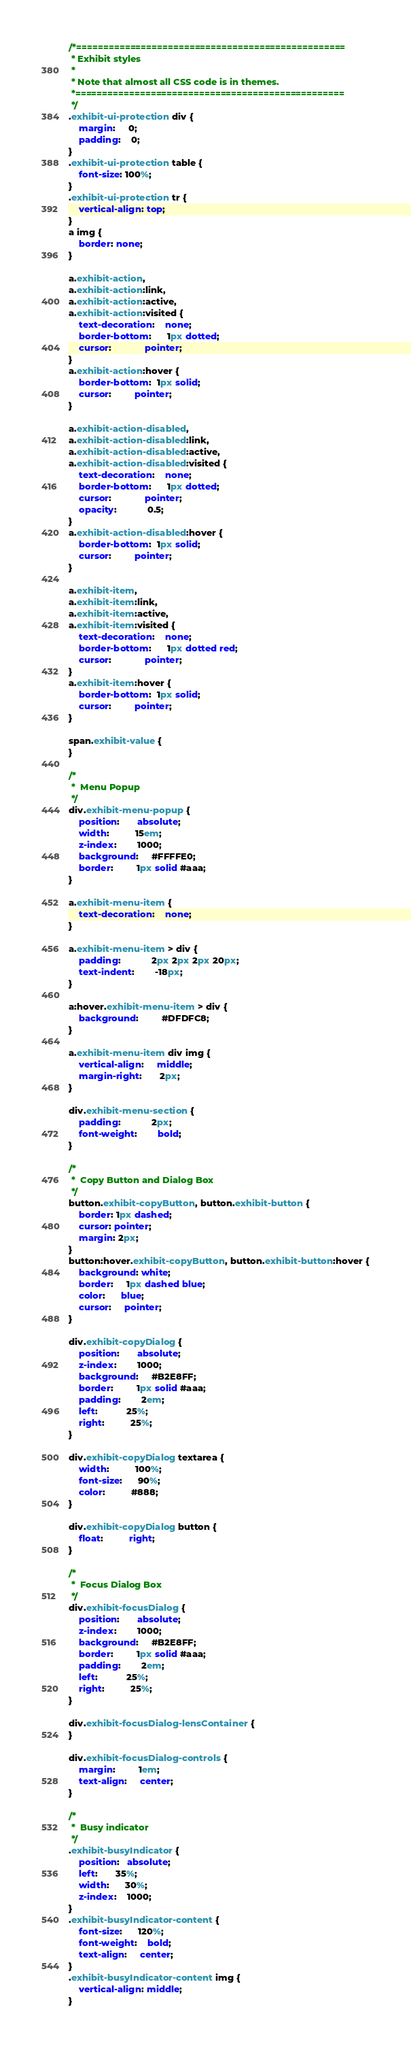Convert code to text. <code><loc_0><loc_0><loc_500><loc_500><_CSS_>/*==================================================
 * Exhibit styles
 *
 * Note that almost all CSS code is in themes.
 *==================================================
 */
.exhibit-ui-protection div {
    margin:     0;
    padding:    0;
}
.exhibit-ui-protection table {
	font-size: 100%;
}
.exhibit-ui-protection tr {
	vertical-align: top;
}
a img {
    border: none;
}

a.exhibit-action, 
a.exhibit-action:link, 
a.exhibit-action:active, 
a.exhibit-action:visited {
	text-decoration:    none;
	border-bottom:      1px dotted;
	cursor:             pointer;
}
a.exhibit-action:hover {
	border-bottom:  1px solid;
	cursor:         pointer;
}

a.exhibit-action-disabled, 
a.exhibit-action-disabled:link, 
a.exhibit-action-disabled:active, 
a.exhibit-action-disabled:visited {
	text-decoration:    none;
	border-bottom:      1px dotted;
	cursor:             pointer;
    opacity:            0.5;
}
a.exhibit-action-disabled:hover {
	border-bottom:  1px solid;
	cursor:         pointer;
}

a.exhibit-item, 
a.exhibit-item:link, 
a.exhibit-item:active, 
a.exhibit-item:visited {
	text-decoration:    none;
	border-bottom:      1px dotted red;
	cursor:             pointer;
}
a.exhibit-item:hover {
	border-bottom:  1px solid;
	cursor:         pointer;
}

span.exhibit-value {
}

/*
 *  Menu Popup
 */
div.exhibit-menu-popup {
    position:       absolute;
    width:          15em;
    z-index:        1000;
    background:     #FFFFE0;
    border:         1px solid #aaa;
}

a.exhibit-menu-item {
    text-decoration:    none;
}

a.exhibit-menu-item > div {
    padding:            2px 2px 2px 20px;
    text-indent:        -18px;
}

a:hover.exhibit-menu-item > div {
    background:         #DFDFC8;
}

a.exhibit-menu-item div img {
    vertical-align:     middle;
    margin-right:       2px;
}

div.exhibit-menu-section {
    padding:            2px;
    font-weight:        bold;
}

/*
 *  Copy Button and Dialog Box
 */
button.exhibit-copyButton, button.exhibit-button {
    border: 1px dashed;
    cursor: pointer;
    margin: 2px;
}
button:hover.exhibit-copyButton, button.exhibit-button:hover {
    background: white;
    border:     1px dashed blue;
    color:      blue;
    cursor:     pointer;
}

div.exhibit-copyDialog {
    position:       absolute;
    z-index:        1000;
    background:     #B2E8FF;
    border:         1px solid #aaa;
    padding:        2em;
    left:           25%;
    right:          25%;
}

div.exhibit-copyDialog textarea {
    width:          100%;
    font-size:      90%;
    color:          #888;
}

div.exhibit-copyDialog button {
    float:          right;
}

/*
 *  Focus Dialog Box
 */
div.exhibit-focusDialog {
    position:       absolute;
    z-index:        1000;
    background:     #B2E8FF;
    border:         1px solid #aaa;
    padding:        2em;
    left:           25%;
    right:          25%;
}

div.exhibit-focusDialog-lensContainer {
}

div.exhibit-focusDialog-controls {
    margin:         1em;
    text-align:     center;
}

/*
 *  Busy indicator
 */
.exhibit-busyIndicator {
    position:   absolute;
    left:       35%;
    width:      30%;
    z-index:    1000;
}
.exhibit-busyIndicator-content {
    font-size:      120%;
    font-weight:    bold;
    text-align:     center;
}
.exhibit-busyIndicator-content img {
    vertical-align: middle;
}
</code> 